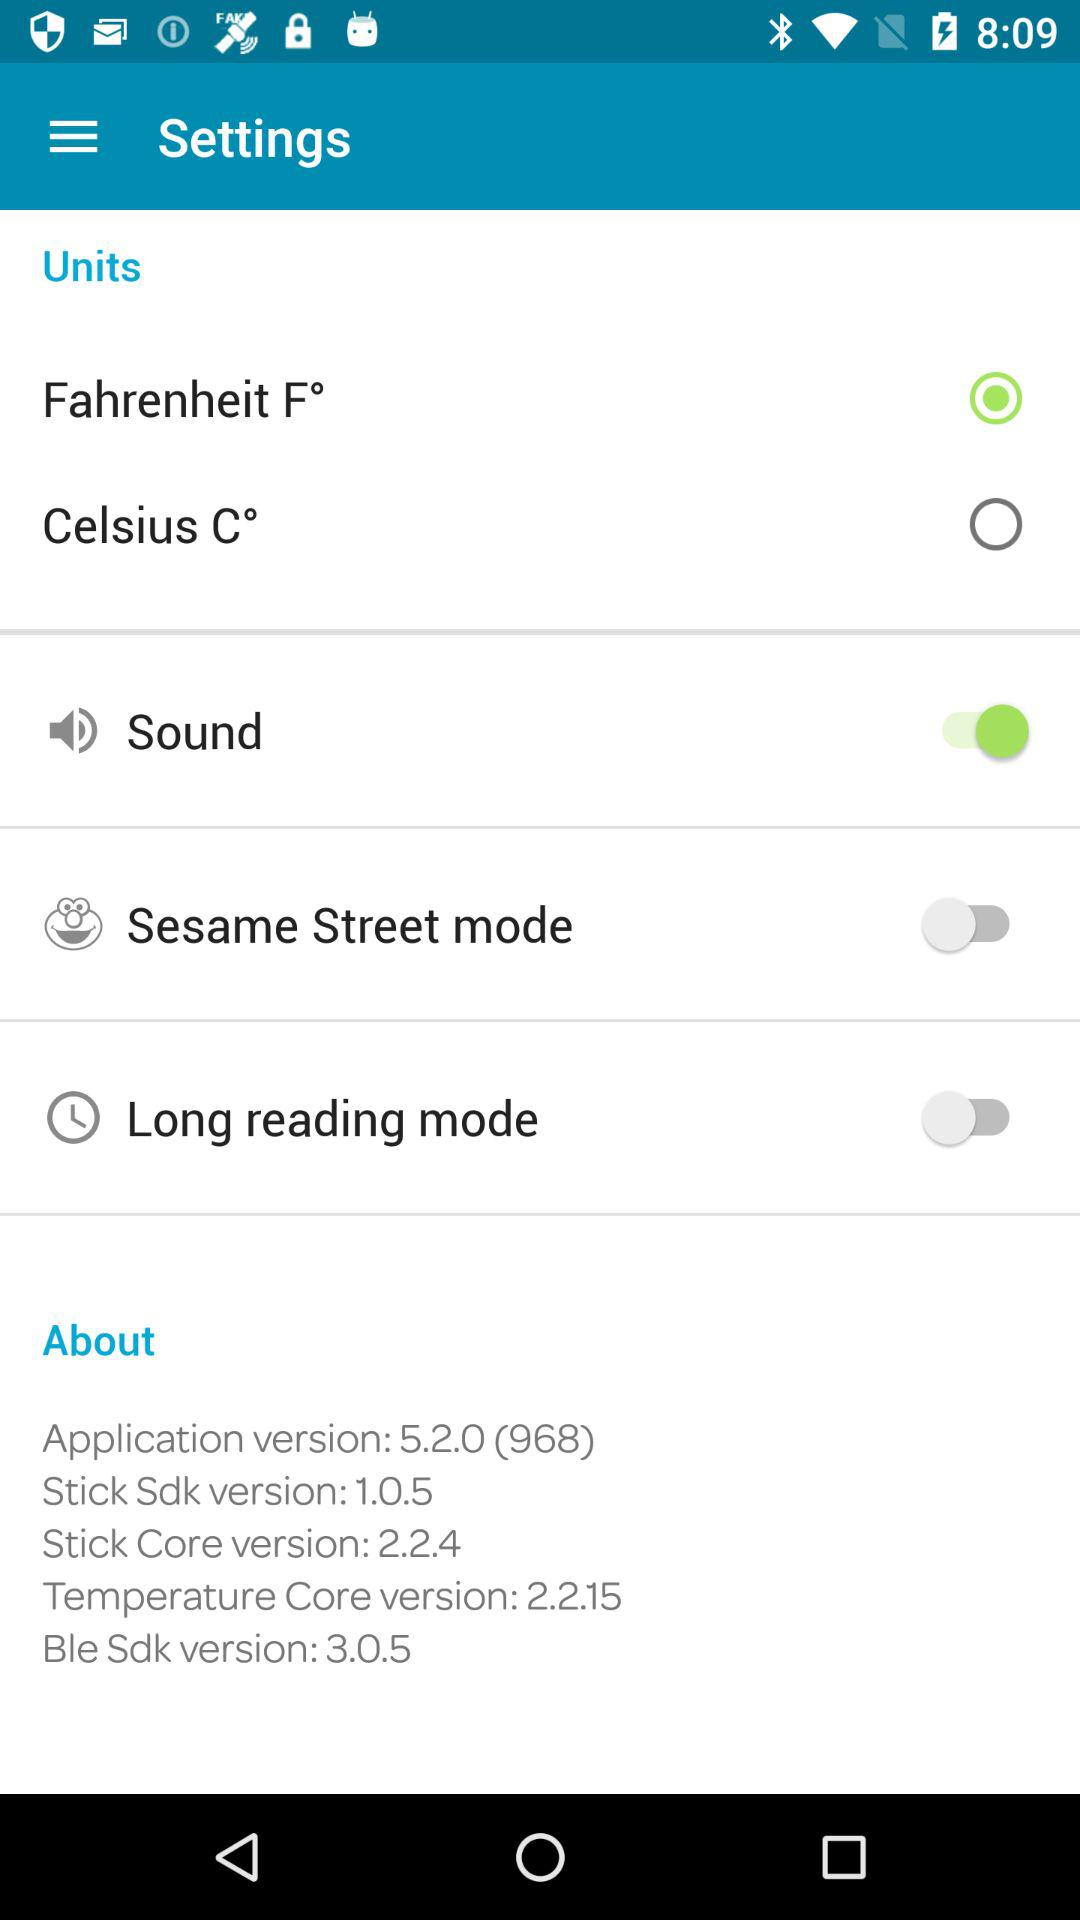What is the status of sound? The status is on. 